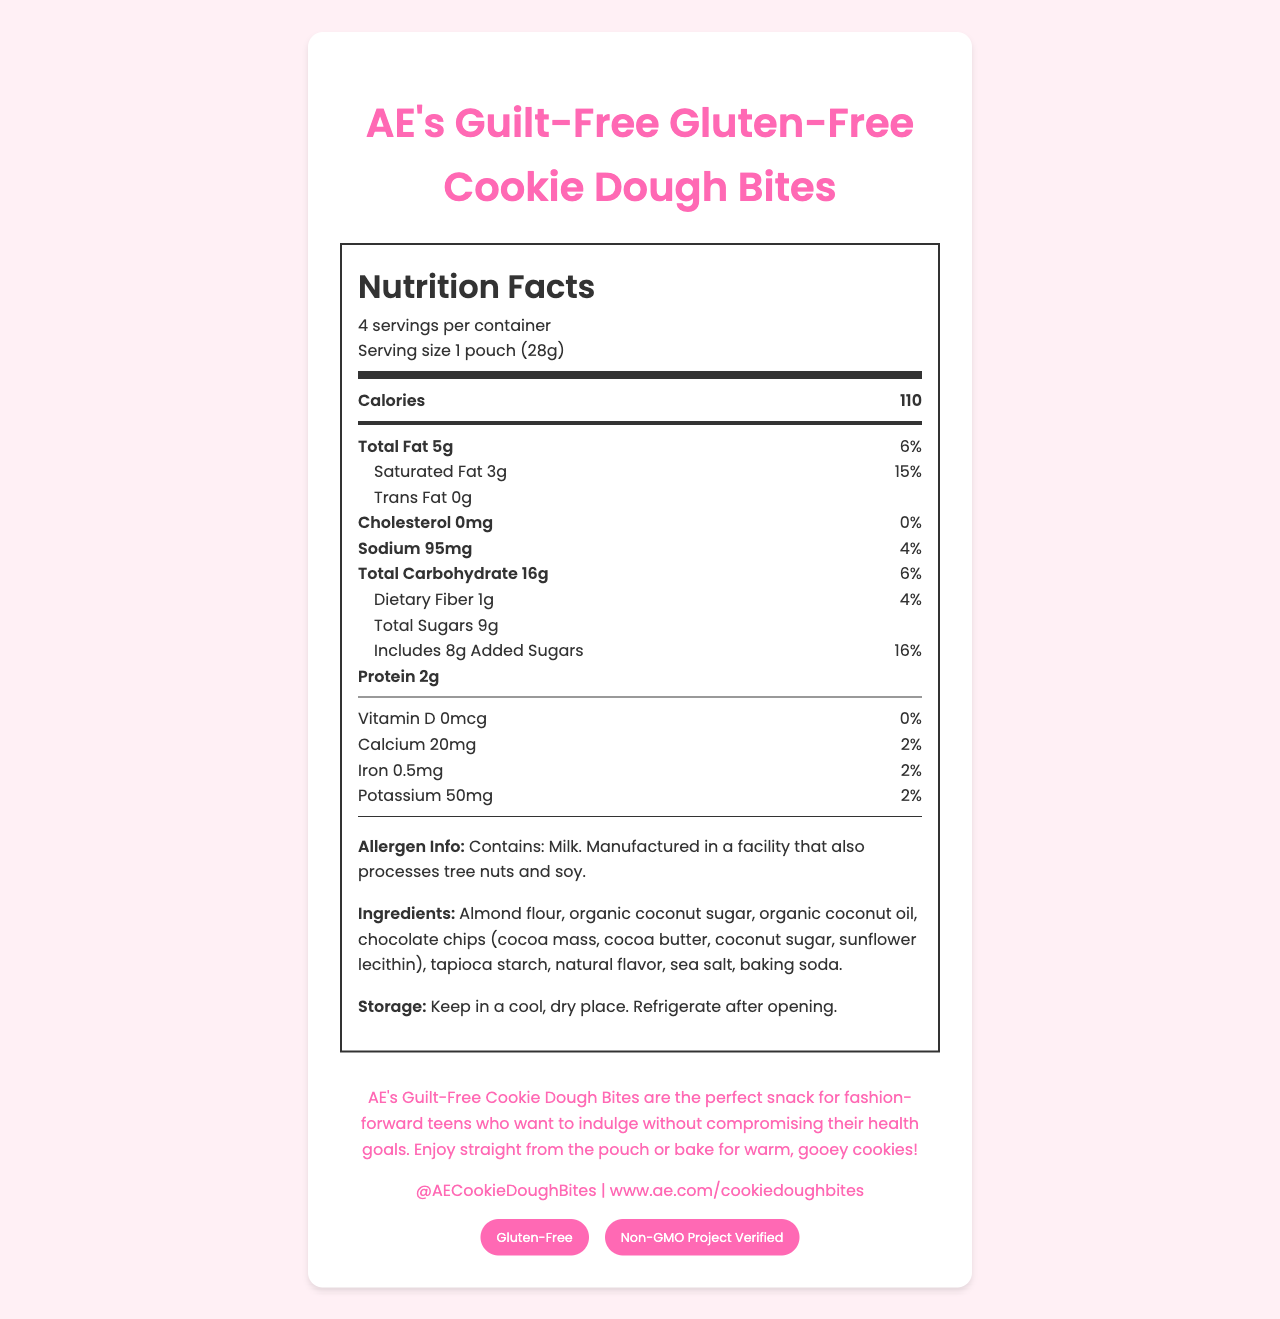what is the serving size of AE's Guilt-Free Gluten-Free Cookie Dough Bites? The serving size is clearly mentioned in the Nutrition Facts section as "1 pouch (28g)".
Answer: 1 pouch (28g) how many calories are in one serving of these cookie dough bites? The number of calories per serving is listed in the main nutrient section as "Calories 110".
Answer: 110 calories how many servings are there in one container? The number of servings per container is mentioned in the Nutrition Facts section as "4 servings per container".
Answer: 4 what is the amount of total fat per serving? The document lists the total fat content under the sub-nutrients section as "Total Fat 5g".
Answer: 5g how much sodium does one serving contain? The sodium content per serving is listed in the sub-nutrients section as "Sodium 95mg".
Answer: 95mg which of the following nutrients has the highest daily value percentage? A. Sodium B. Saturated Fat C. Added Sugars Saturated fat has the highest daily value percentage at 15%, compared to sodium at 4% and added sugars at 16%.
Answer: B. Saturated Fat which ingredient is listed first in the ingredients list? A. Organic Coconut Oil B. Almond Flour C. Chocolate Chips According to the ingredients list, almond flour is listed first.
Answer: B. Almond Flour do the cookie dough bites contain any cholesterol? The sub-nutrients section lists "Cholesterol 0mg (0%)", indicating there is no cholesterol.
Answer: No Are these cookie dough bites gluten-free? The document certifies the product as "Gluten-Free".
Answer: Yes summarize the entire document. This summary captures the essential details about the product's nutrition, ingredients, certifications, and storage instructions.
Answer: AE's Guilt-Free Gluten-Free Cookie Dough Bites provide nutrition facts that include details on serving size (1 pouch, 28g), servings per container (4), and caloric content (110 calories per serving). The document lists amounts and daily values for fats, cholesterol, sodium, carbohydrates, sugars, protein, and essential vitamins and minerals. The product is described as gluten-free and non-GMO, containing allergens like milk and potentially nuts and soy. Ingredients include almond flour and organic coconut sugar. Storage instructions advise keeping the product in a cool, dry place and refrigerating after opening. what is the content of added sugars per serving? The sub-nutrients section lists the amount of added sugars per serving as "8g".
Answer: 8g what is the brand's social media handle? The brand's social media handle is mentioned at the bottom of the document.
Answer: @AECookieDoughBites what percentage of the daily value of calcium is in one serving? The sub-nutrients section lists calcium amount as "20mg" with a daily value percentage of "2%".
Answer: 2% what specific allergens are noted in the allergen information? The allergen information section mentions that the product contains milk and is manufactured in a facility that processes tree nuts and soy.
Answer: Milk and potential tree nuts and soy can the cookie dough bites be baked? The brand statement explicitly states that you can "enjoy straight from the pouch or bake for warm, gooey cookies!"
Answer: Yes what is the total carbohydrate content per serving? The total carbohydrate content per serving is listed as "16g" in the sub-nutrients section.
Answer: 16g is there any trans fat in these cookie dough bites? The sub-nutrients section indicates "Trans Fat 0g", meaning there is no trans fat present.
Answer: No what is the official website for more information about this product? The website is listed at the bottom of the document.
Answer: www.ae.com/cookiedoughbites are these cookie dough bites certified non-GMO? The document lists one of the certifications as "Non-GMO Project Verified".
Answer: Yes who would most likely enjoy AE's Guilt-Free Cookie Dough Bites according to the brand statement? The brand statement mentions that these cookie dough bites are perfect for "fashion-forward teens who want to indulge without compromising their health goals".
Answer: Fashion-forward teens who want to indulge without compromising their health goals what is the percentage of the daily value for iron per serving? The sub-nutrients section mentions that the iron content per serving is "0.5mg" with a daily value of "2%".
Answer: 2% how much dietary fiber is in one serving? The sub-nutrients section lists dietary fiber content as "1g".
Answer: 1g how much protein is in one serving of these cookie dough bites? Protein content per serving is mentioned as "2g".
Answer: 2g can the exact process of how the cookie dough bites are manufactured be determined from the document? The document does not provide details about the manufacturing process.
Answer: Not enough information 